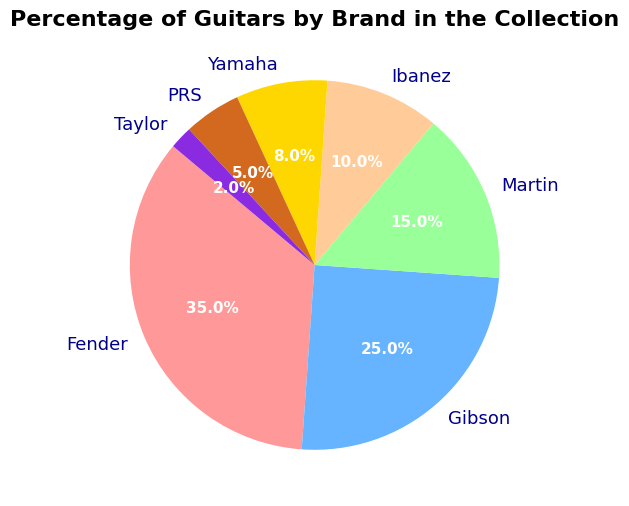What percentage of the collection is made up of Fender and Gibson guitars combined? To find the combined percentage of Fender and Gibson guitars, add the two percentages together: 35% (Fender) + 25% (Gibson) = 60%.
Answer: 60% Which brand makes up the smallest percentage of the guitar collection? By comparing the percentages in the pie chart, Taylor has the smallest percentage at 2%.
Answer: Taylor How much greater is the percentage of Fender guitars compared to Yamaha guitars? Subtract the percentage of Yamaha (8%) from the percentage of Fender (35%): 35% - 8% = 27%.
Answer: 27% Are there more Ibanez or PRS guitars in the collection? By comparing the percentages, Ibanez (10%) has more representation than PRS (5%).
Answer: Ibanez What is the average percentage of the three largest brands in the collection? The three largest brands by percentage are Fender (35%), Gibson (25%), and Martin (15%). To find the average, add their percentages and divide by 3: (35 + 25 + 15) / 3 = 25%.
Answer: 25% What is the total percentage of guitars from brands not among the three largest brands? First, sum the percentages of the three largest brands: Fender (35%), Gibson (25%), and Martin (15%). The total is 75%. Subtract this from 100% to find the percentage of the remaining brands: 100% - 75% = 25%.
Answer: 25% How many brands have a greater percentage than Yamaha in the collection? By comparing percentages, there are four brands with greater percentages than Yamaha (8%): Fender (35%), Gibson (25%), Martin (15%), and Ibanez (10%).
Answer: 4 What is the difference in percentage between the largest and the smallest brand? Calculate the difference by subtracting the smallest percentage (Taylor 2%) from the largest percentage (Fender 35%): 35% - 2% = 33%.
Answer: 33% If Gibson guitars increased their percentage by 10%, how would their new percentage compare to Fender’s current percentage? Adding 10% to Gibson's 25% gives 35%. This makes Gibson's new percentage 35%, which is equal to Fender's current percentage of 35%.
Answer: Equal 